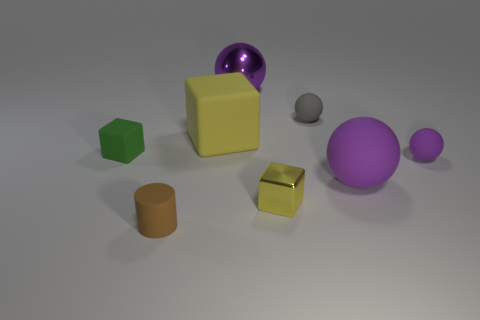Subtract all cyan blocks. How many purple balls are left? 3 Add 1 small green objects. How many objects exist? 9 Subtract all blocks. How many objects are left? 5 Subtract 0 yellow spheres. How many objects are left? 8 Subtract all blue matte objects. Subtract all green blocks. How many objects are left? 7 Add 3 green objects. How many green objects are left? 4 Add 2 small yellow rubber cubes. How many small yellow rubber cubes exist? 2 